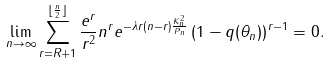<formula> <loc_0><loc_0><loc_500><loc_500>\lim _ { n \rightarrow \infty } \sum _ { r = R + 1 } ^ { \lfloor \frac { n } { 2 } \rfloor } \frac { e ^ { r } } { r ^ { 2 } } n ^ { r } e ^ { - \lambda r ( n - r ) \frac { K ^ { 2 } _ { n } } { P _ { n } } } \left ( 1 - q ( \theta _ { n } ) \right ) ^ { r - 1 } = 0 .</formula> 